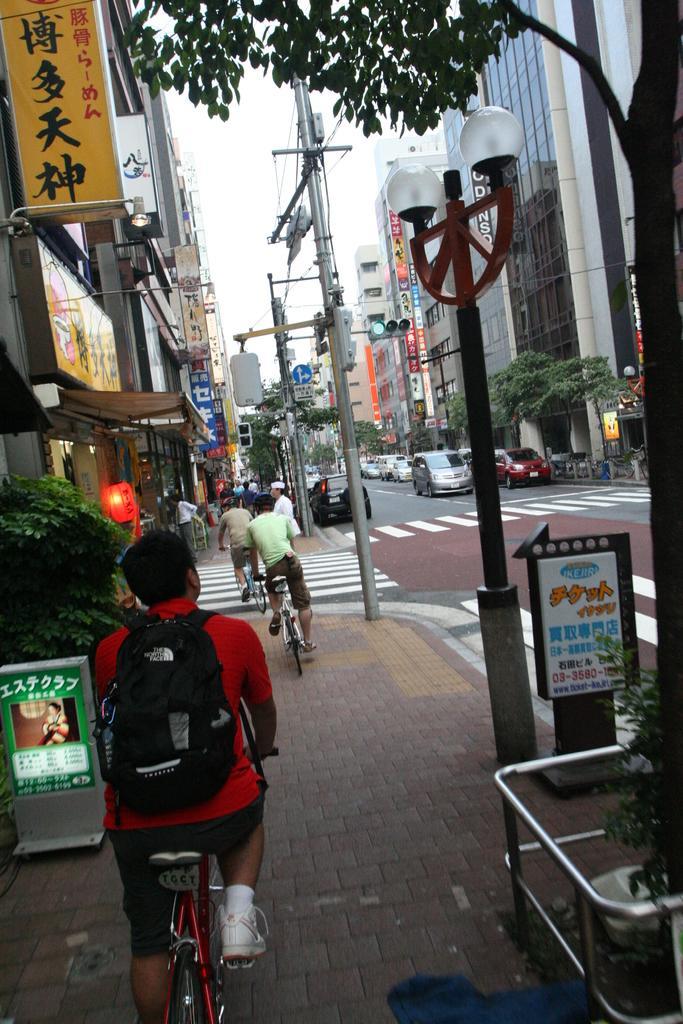Describe this image in one or two sentences. In this image a person is sitting on the bi-cycle is wearing a red shirt and carrying a bag is wearing wearing shoes and socks is riding on pavement beside road. Before there are two persons riding on bicycle. At the right side there is a pole on the pavement. There are few cars on the road. There are trees on both sides of the roads. At the right side there is a building. Middle of image there is a sky. At the left side there is a plant behind to it there is a building. 